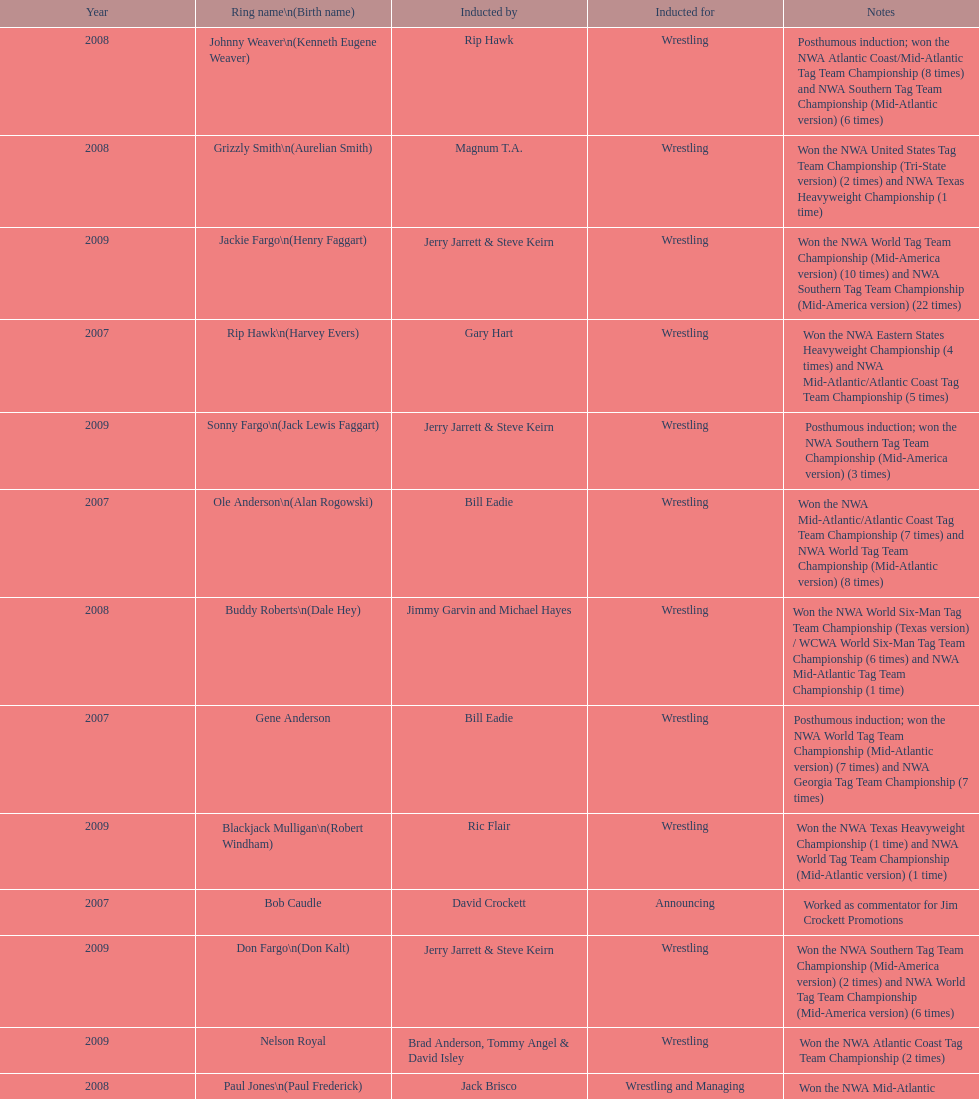Who's real name is dale hey, grizzly smith or buddy roberts? Buddy Roberts. 